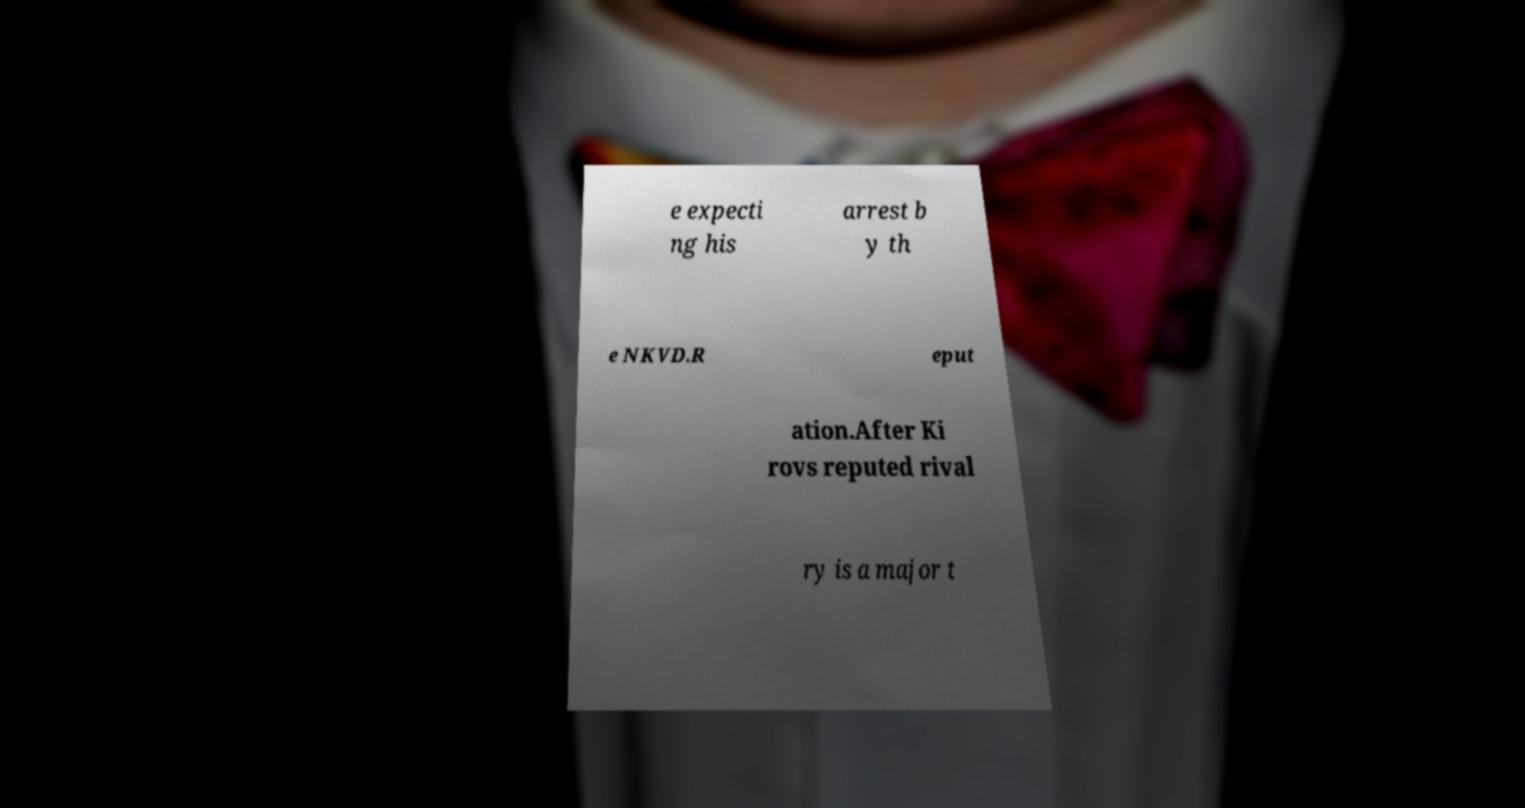Can you read and provide the text displayed in the image?This photo seems to have some interesting text. Can you extract and type it out for me? e expecti ng his arrest b y th e NKVD.R eput ation.After Ki rovs reputed rival ry is a major t 